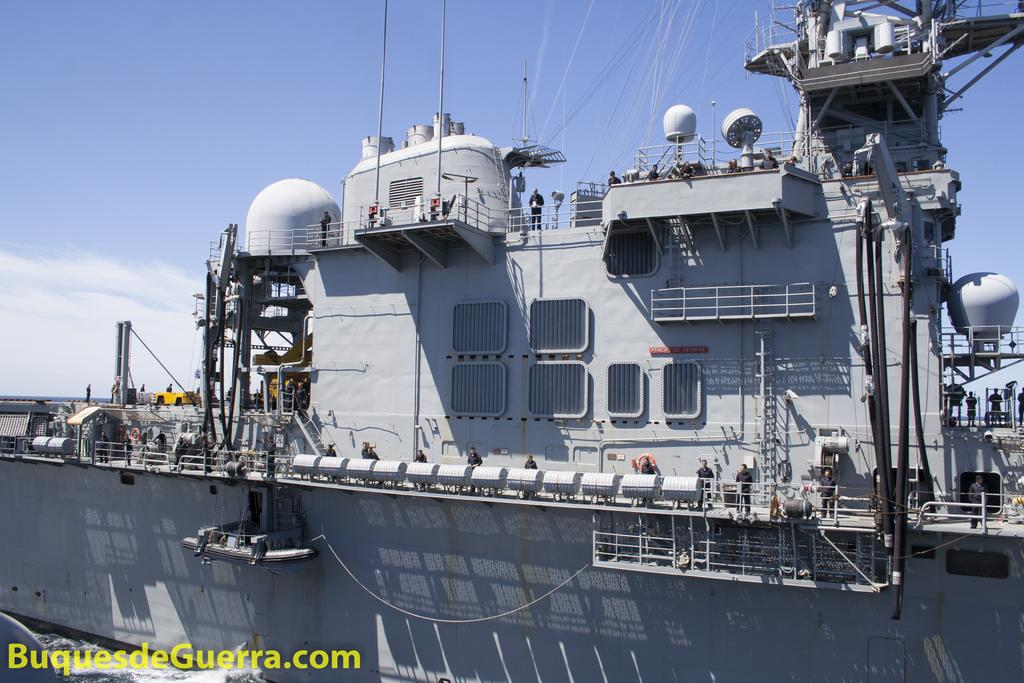What is the main subject of the image? The main subject of the image is a big ship. What color is the ship? The ship is grey in color. Can you describe the people on the ship? There are many people on the ship, and they are wearing black dress. What can be seen in the sky in the image? There are clouds visible in the sky. What type of caption is written on the bread in the image? There is no bread present in the image, so there cannot be a caption written on it. 